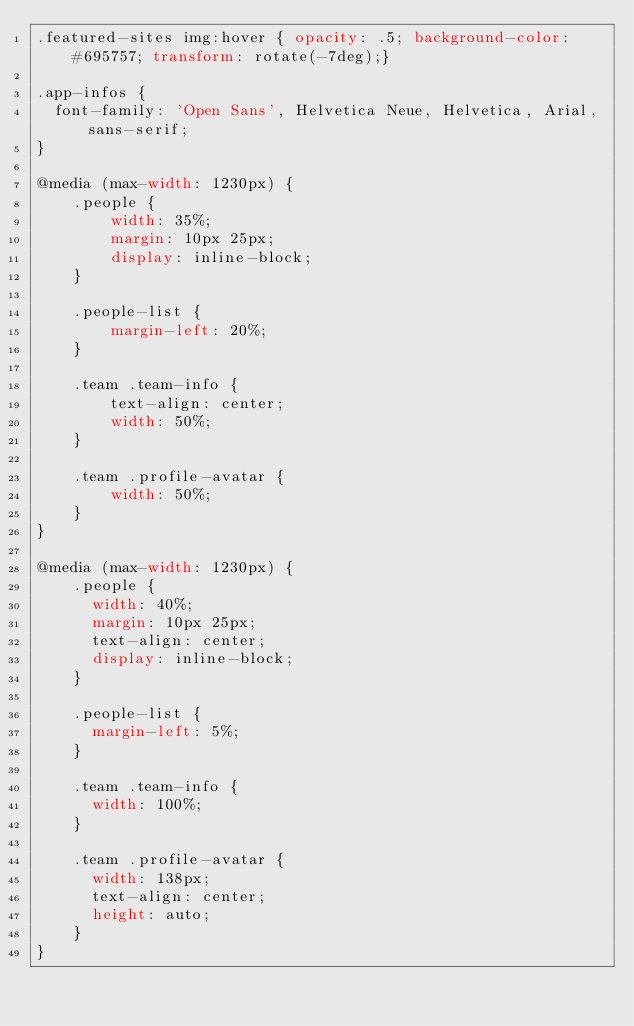Convert code to text. <code><loc_0><loc_0><loc_500><loc_500><_CSS_>.featured-sites img:hover { opacity: .5; background-color: #695757; transform: rotate(-7deg);}

.app-infos {
  font-family: 'Open Sans', Helvetica Neue, Helvetica, Arial, sans-serif;
}

@media (max-width: 1230px) {
    .people {
        width: 35%;
        margin: 10px 25px;
        display: inline-block;
    }

    .people-list {
        margin-left: 20%;
    }

    .team .team-info {
        text-align: center;
        width: 50%;
    }

    .team .profile-avatar {
        width: 50%;
    }
}

@media (max-width: 1230px) {
    .people {
      width: 40%;
      margin: 10px 25px;
      text-align: center;
      display: inline-block;
    }

    .people-list {
      margin-left: 5%;
    }

    .team .team-info {
      width: 100%;
    }

    .team .profile-avatar {
      width: 138px;
      text-align: center;
      height: auto;
    }
}
</code> 